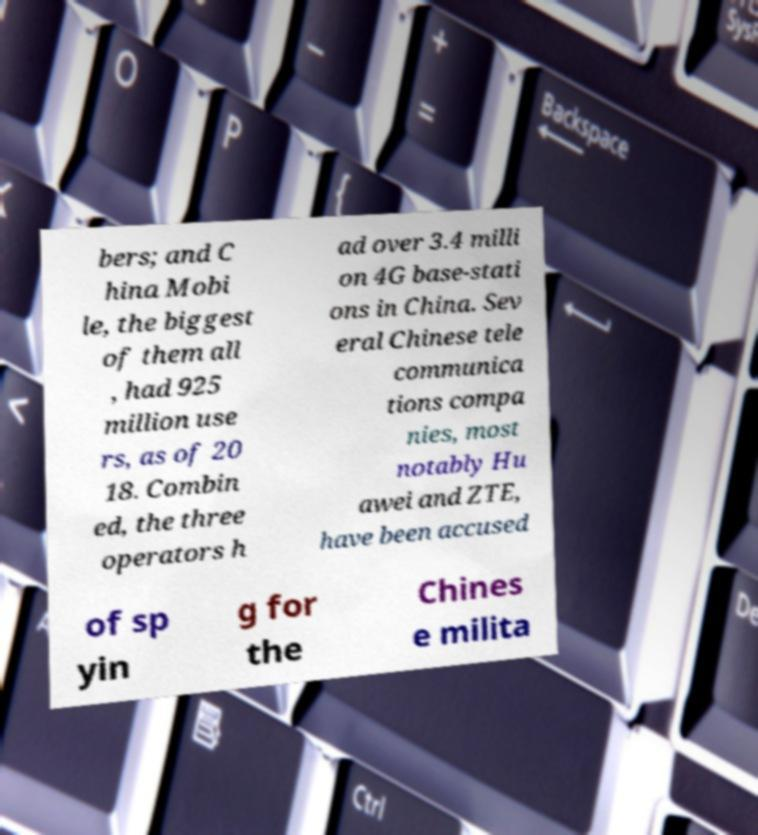What messages or text are displayed in this image? I need them in a readable, typed format. bers; and C hina Mobi le, the biggest of them all , had 925 million use rs, as of 20 18. Combin ed, the three operators h ad over 3.4 milli on 4G base-stati ons in China. Sev eral Chinese tele communica tions compa nies, most notably Hu awei and ZTE, have been accused of sp yin g for the Chines e milita 